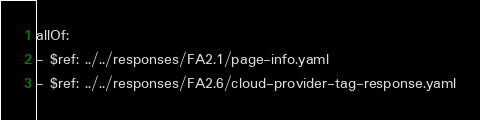Convert code to text. <code><loc_0><loc_0><loc_500><loc_500><_YAML_>allOf:
- $ref: ../../responses/FA2.1/page-info.yaml
- $ref: ../../responses/FA2.6/cloud-provider-tag-response.yaml
</code> 